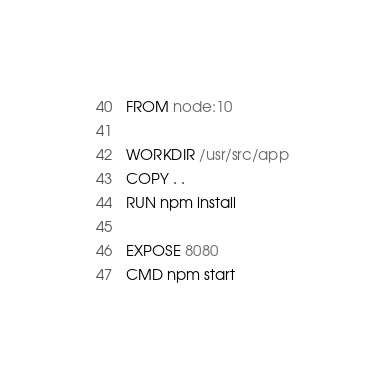Convert code to text. <code><loc_0><loc_0><loc_500><loc_500><_Dockerfile_>FROM node:10

WORKDIR /usr/src/app
COPY . .
RUN npm install

EXPOSE 8080
CMD npm start
</code> 